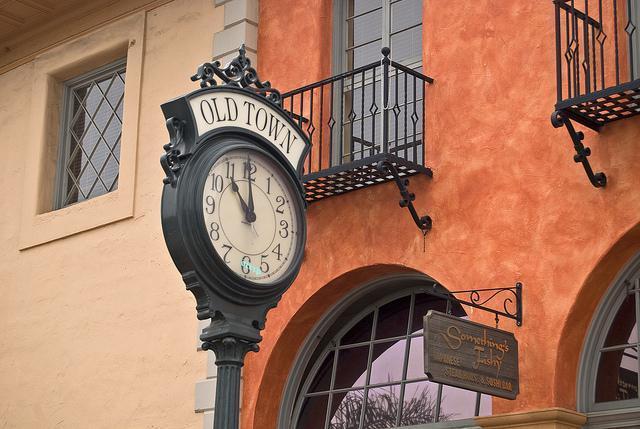How many forks are on the plate?
Give a very brief answer. 0. 